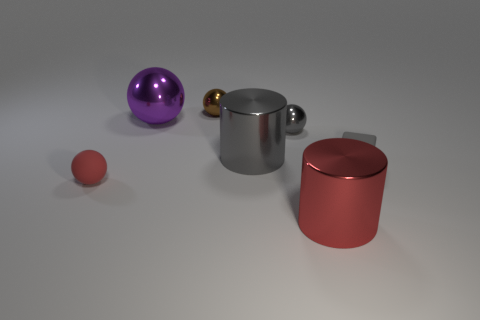Subtract all shiny balls. How many balls are left? 1 Add 3 big purple spheres. How many objects exist? 10 Subtract all gray cylinders. How many cylinders are left? 1 Subtract all cubes. How many objects are left? 6 Subtract all brown blocks. Subtract all blue cylinders. How many blocks are left? 1 Subtract all tiny yellow matte objects. Subtract all rubber blocks. How many objects are left? 6 Add 4 tiny gray shiny spheres. How many tiny gray shiny spheres are left? 5 Add 1 tiny gray blocks. How many tiny gray blocks exist? 2 Subtract 0 cyan blocks. How many objects are left? 7 